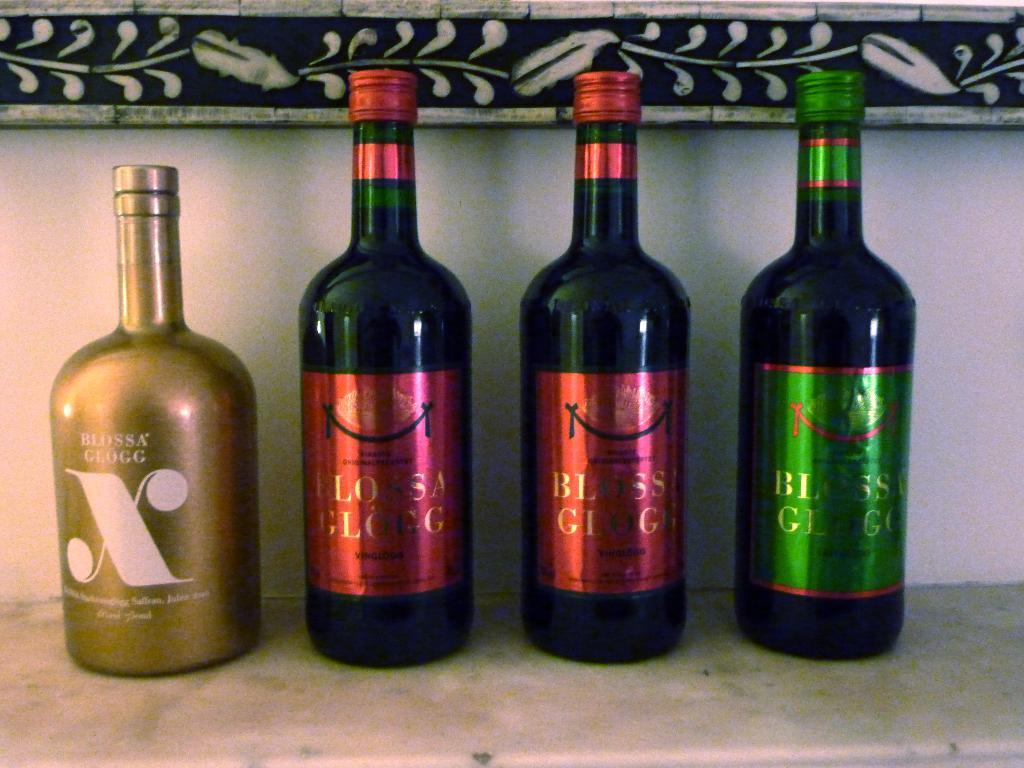<image>
Offer a succinct explanation of the picture presented. The wine in the golden bottle is from Blossa Glogg 